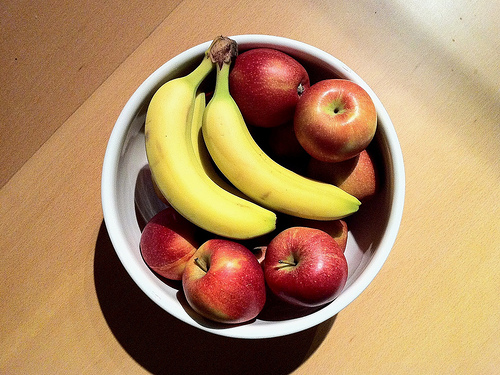<image>
Is there a banana to the right of the bowl? No. The banana is not to the right of the bowl. The horizontal positioning shows a different relationship. Where is the fruits in relation to the table? Is it on the table? Yes. Looking at the image, I can see the fruits is positioned on top of the table, with the table providing support. Is there a banana next to the apple? Yes. The banana is positioned adjacent to the apple, located nearby in the same general area. Is the banana to the left of the apple? Yes. From this viewpoint, the banana is positioned to the left side relative to the apple. Is the apple above the table? Yes. The apple is positioned above the table in the vertical space, higher up in the scene. 